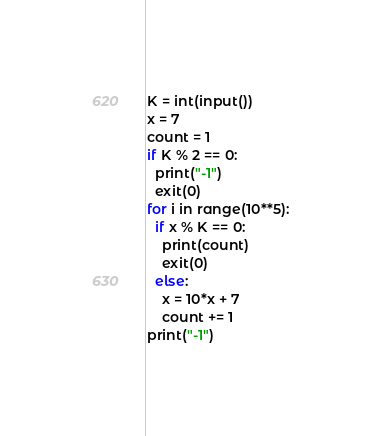Convert code to text. <code><loc_0><loc_0><loc_500><loc_500><_Python_>K = int(input())
x = 7
count = 1
if K % 2 == 0:
  print("-1")
  exit(0)
for i in range(10**5):
  if x % K == 0:
    print(count)
    exit(0)
  else:
    x = 10*x + 7
    count += 1
print("-1")</code> 